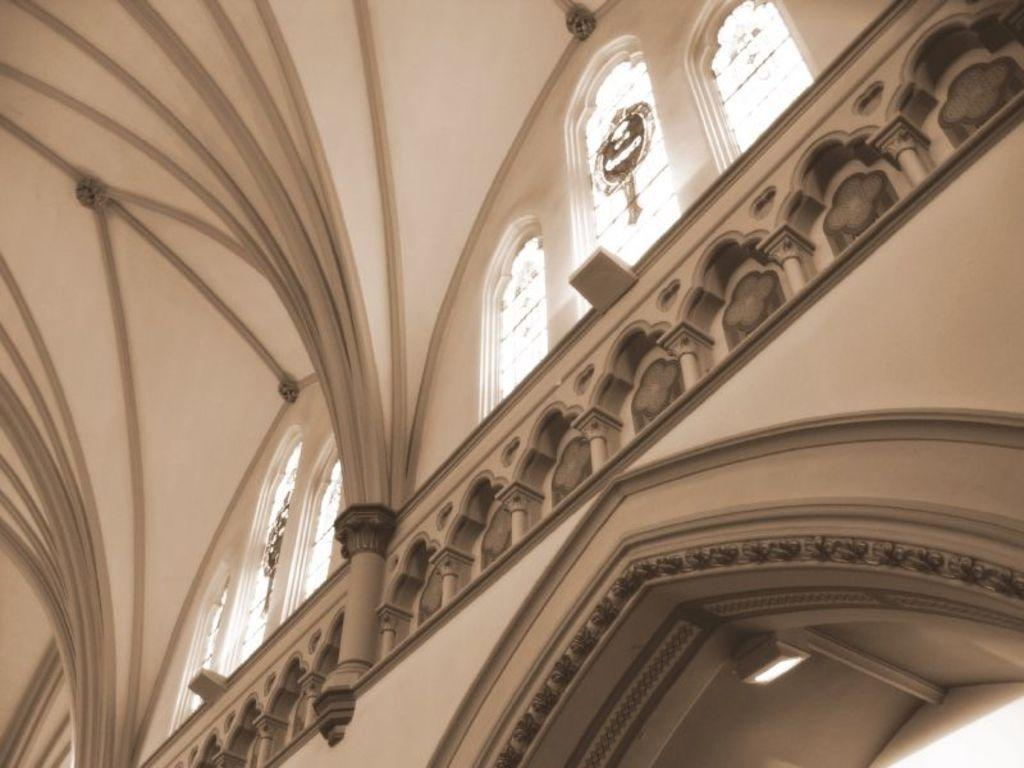What type of view is shown in the image? The image shows the inner view of a building. Can you describe any specific features of the building's interior? There is a light attached to the ceiling in the building. What type of windows are present in the building? There are glass windows in the building. How many brains can be seen in the image? There are no brains visible in the image; it shows the interior of a building. What type of error is being corrected in the image? There is no indication of an error being corrected in the image. 